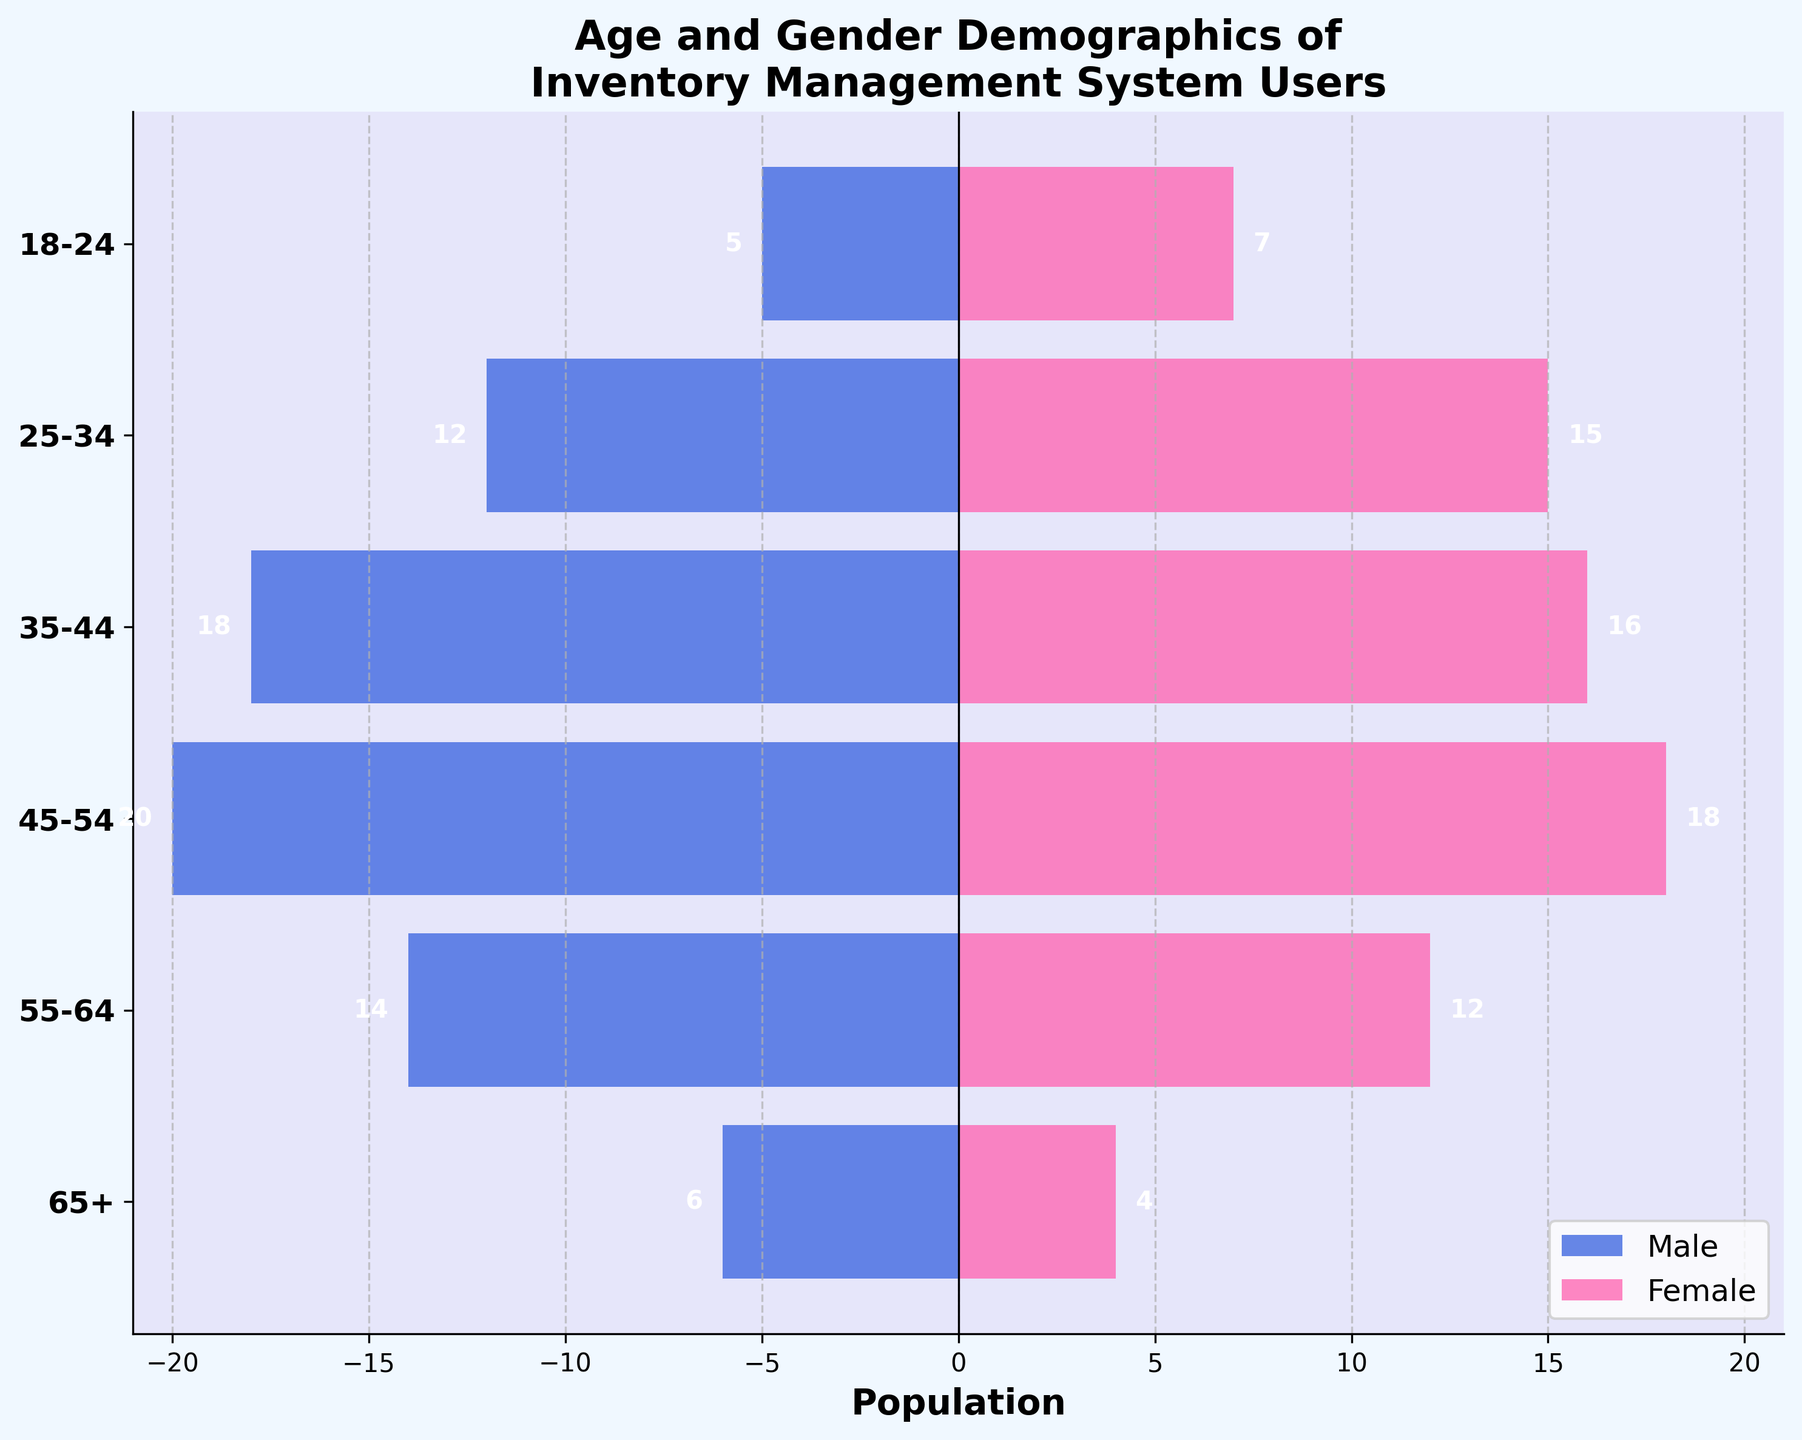Which age group has the highest number of female users? To determine the age group with the highest number of female users, we look at the bar's length representing each age group. The 25-34 age group has the longest bar.
Answer: 25-34 Which age group has the most balanced gender distribution? To find the most balanced gender distribution, we compare the lengths of the male and female bars for each age group. The 35-44 and 55-64 age groups appear most balanced, though the former shows a slight male predominance and the latter a slight female predominance.
Answer: 35-44 How many total users are in the 45-54 age group? Summing the male and female users in the 45-54 age group, 20 males and 18 females gives 20 + 18 = 38.
Answer: 38 What percentage of the total user base is in the 18-24 age group? First, find the total number of users by summing all values for all age groups: 5+7+12+15+18+16+20+18+14+12+6+4 = 147. Then, calculate the percentage for the 18-24 group: (5+7)/147 ≈ 8.16%.
Answer: 8.16% Which gender has more users in the 65+ age group? By comparing the number of users in the 65+ age group, males have 6 and females have 4. Males are more.
Answer: Male How does the number of users in the 25-34 age group compare to the 55-64 age group? The 25-34 age group has 12 males and 15 females totaling 27 users. The 55-64 age group has 14 males and 12 females totaling 26 users. Therefore, the 25-34 age group has 1 more user than the 55-64 age group.
Answer: 25-34 has 1 more user What is the difference in the number of male users between the 35-44 and 45-54 age groups? The number of male users in the 35-44 age group is 18, and in the 45-54 age group, it is 20. The difference is 20 - 18 = 2.
Answer: 2 What is the combined total of female users in the 35-44 and 45-54 age groups? Sum the number of female users in both age groups: 16 (35-44) + 18 (45-54) = 34.
Answer: 34 